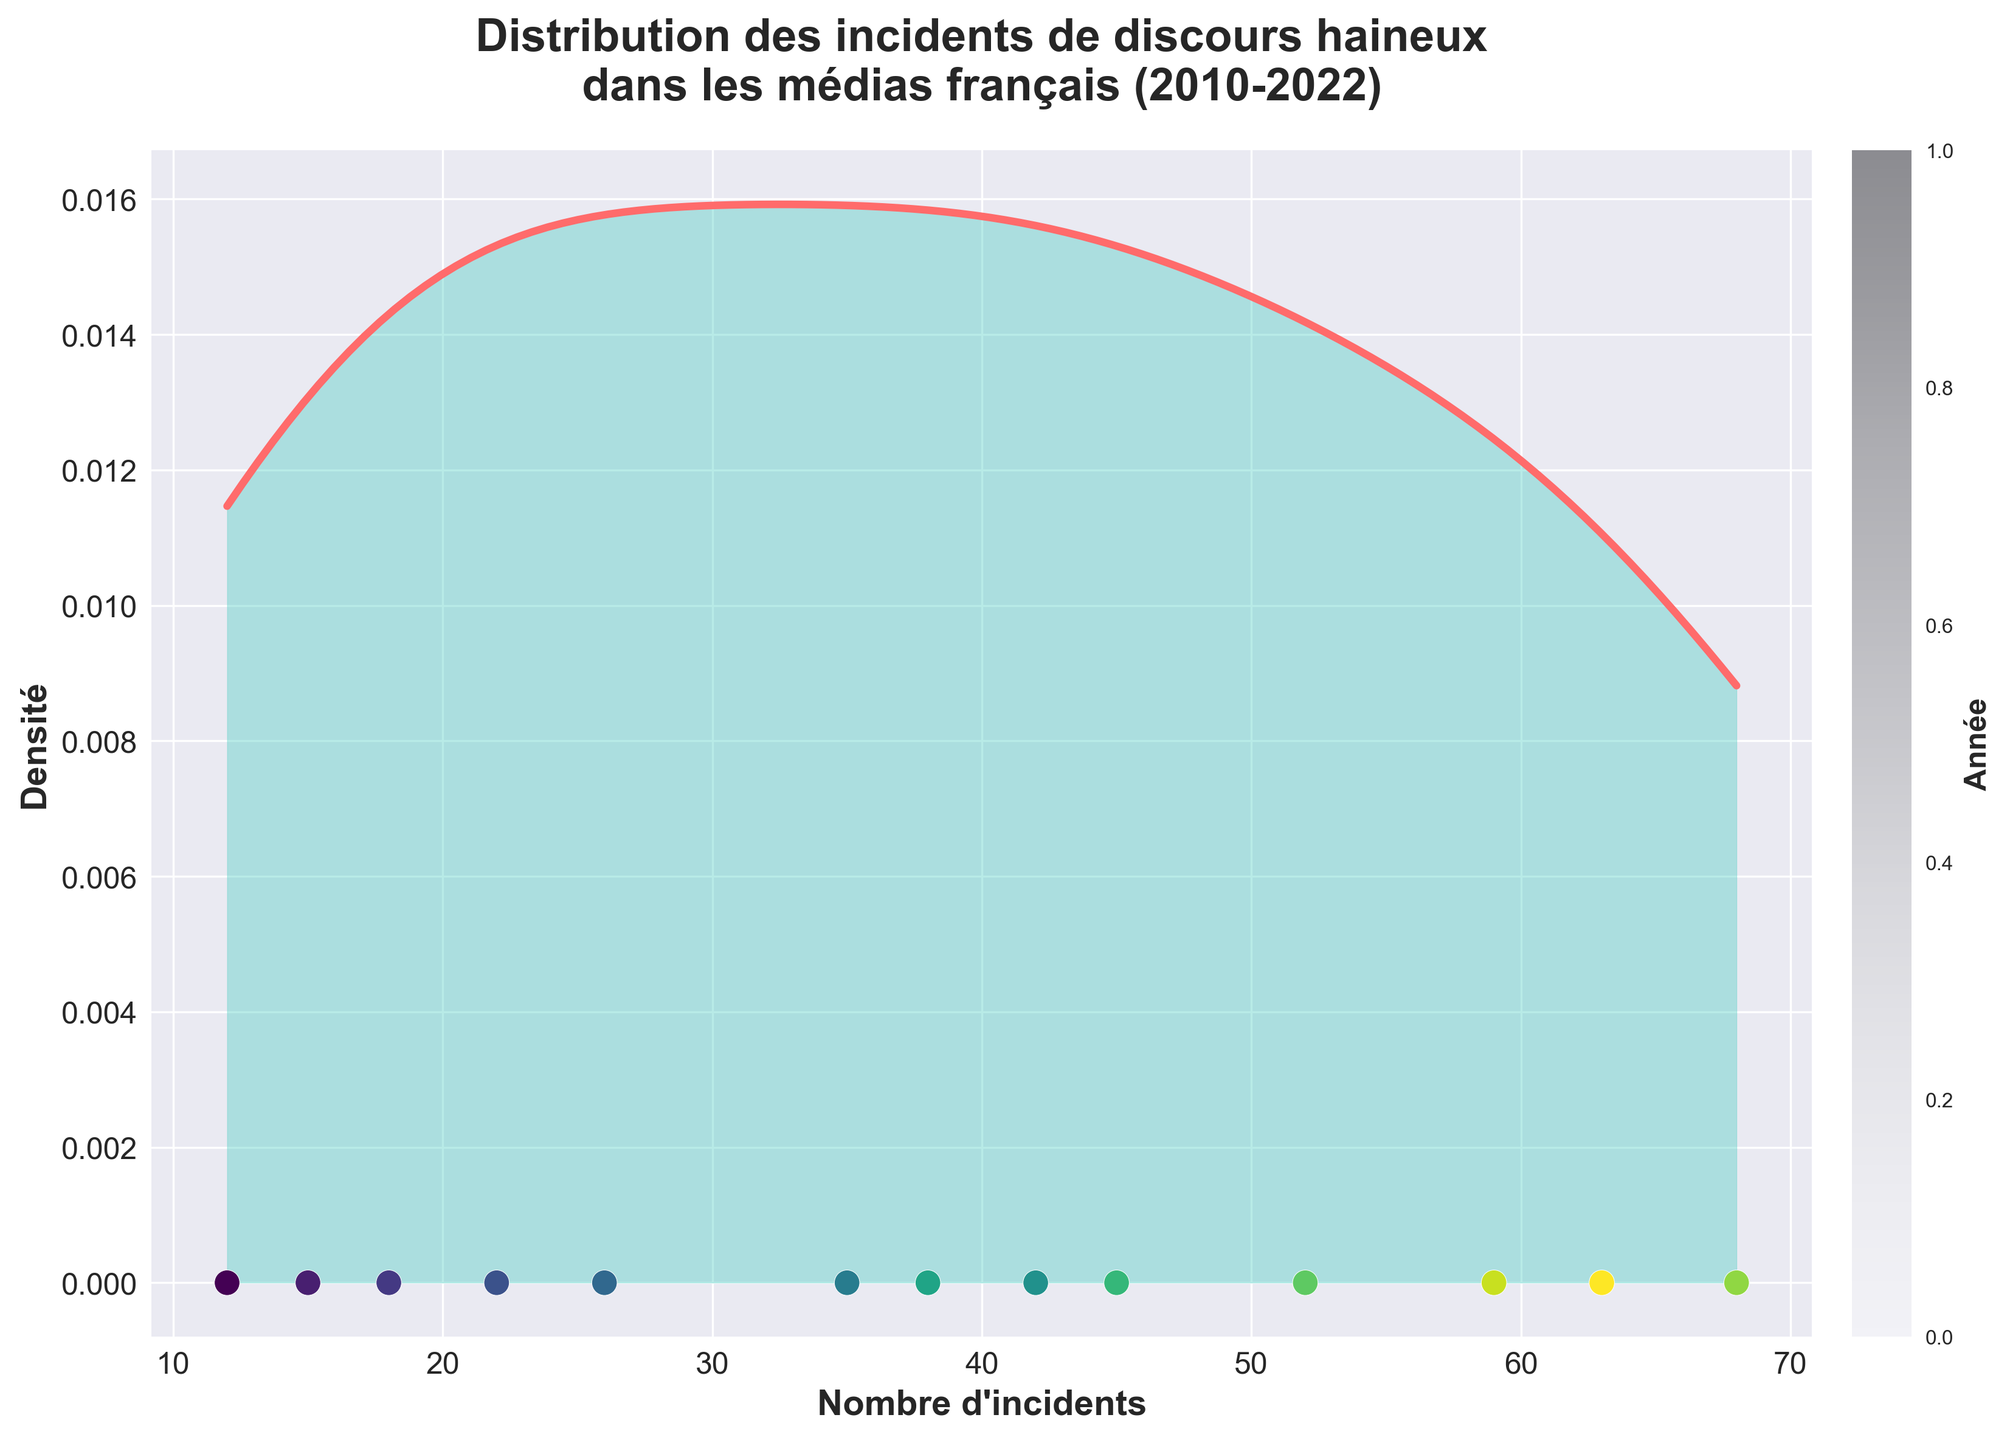What is the title of the figure? The title of the figure is written in large font and bold at the top of the chart.
Answer: Distribution des incidents de discours haineux dans les médias français (2010-2022) What does the x-axis represent? The x-axis is labeled in bold text at the bottom of the chart.
Answer: Nombre d'incidents What does the y-axis represent? The y-axis is labeled in bold text on the left side of the chart.
Answer: Densité What is the color used to fill the area under the density curve? The area under the density curve is filled with a transparent shade of a specific color.
Answer: Light green What is the highest density value reached in the graph? The y-axis shows the density values, and the highest point on the density curve represents the highest density value.
Answer: Approximately 0.016 How many incident data points are shown on the graph? The scatter plot shows incident data points along the x-axis at the bottom of the chart. Count these points.
Answer: 13 Between which range of incidents does the density peak occur? The density peak occurs where the density curve reaches its maximum value on the x-axis. Examine the range around this peak.
Answer: Between 40 and 55 incidents How does the number of hate speech incidents change over time? Look at the scatter plot colored by year to observe the trend in incidents over time.
Answer: It increases overall Which year has the highest number of incidents and what is this number? The scatter plot with colored markers indicates the number of incidents for each year. The highest point corresponds to the specific year.
Answer: 2020, 68 incidents What is the trend of incidents between the years 2016 and 2020? Find the points corresponding to these years on the scatter plot and observe their progression.
Answer: The number of incidents increases 